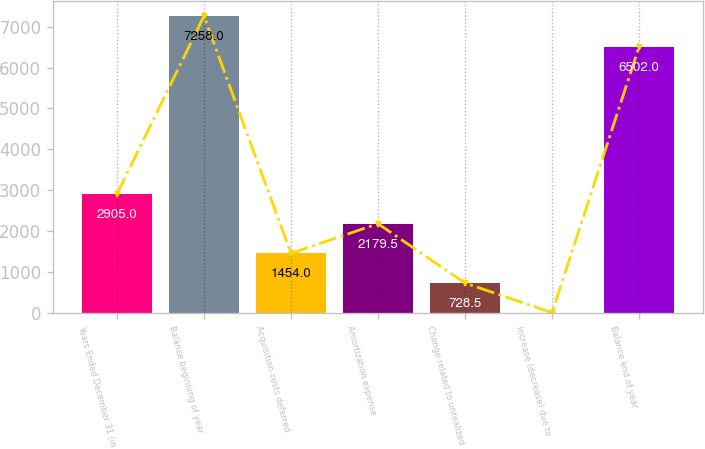<chart> <loc_0><loc_0><loc_500><loc_500><bar_chart><fcel>Years Ended December 31 (in<fcel>Balance beginning of year<fcel>Acquisition costs deferred<fcel>Amortization expense<fcel>Change related to unrealized<fcel>Increase (decrease) due to<fcel>Balance end of year<nl><fcel>2905<fcel>7258<fcel>1454<fcel>2179.5<fcel>728.5<fcel>3<fcel>6502<nl></chart> 